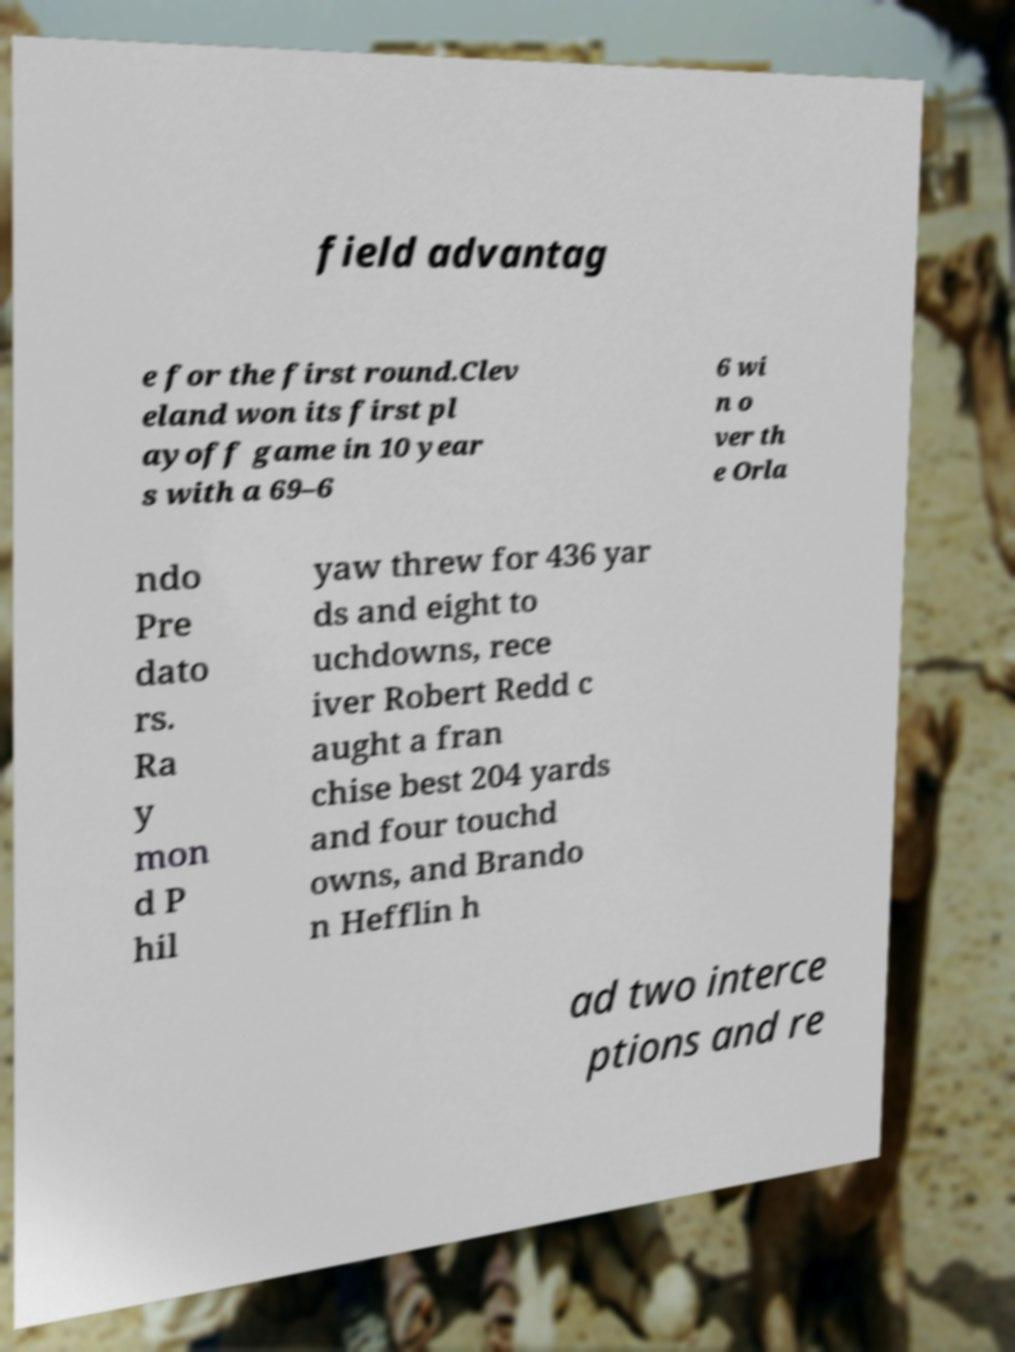Can you read and provide the text displayed in the image?This photo seems to have some interesting text. Can you extract and type it out for me? field advantag e for the first round.Clev eland won its first pl ayoff game in 10 year s with a 69–6 6 wi n o ver th e Orla ndo Pre dato rs. Ra y mon d P hil yaw threw for 436 yar ds and eight to uchdowns, rece iver Robert Redd c aught a fran chise best 204 yards and four touchd owns, and Brando n Hefflin h ad two interce ptions and re 